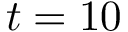Convert formula to latex. <formula><loc_0><loc_0><loc_500><loc_500>t = 1 0</formula> 